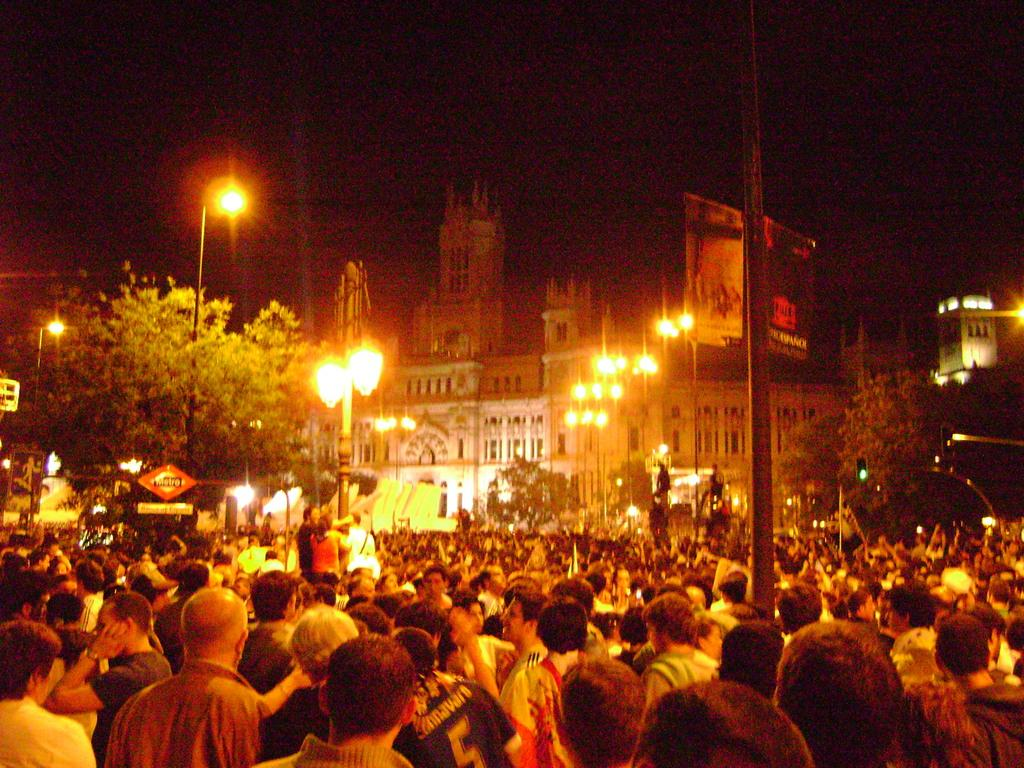What is located in the foreground of the image? There is a crowd in the foreground of the image. What can be seen in the background of the image? There are poles, trees, buildings, lights, and a dark sky visible in the background of the image. What type of berry can be seen growing on the lace in the image? There is no berry or lace present in the image. 